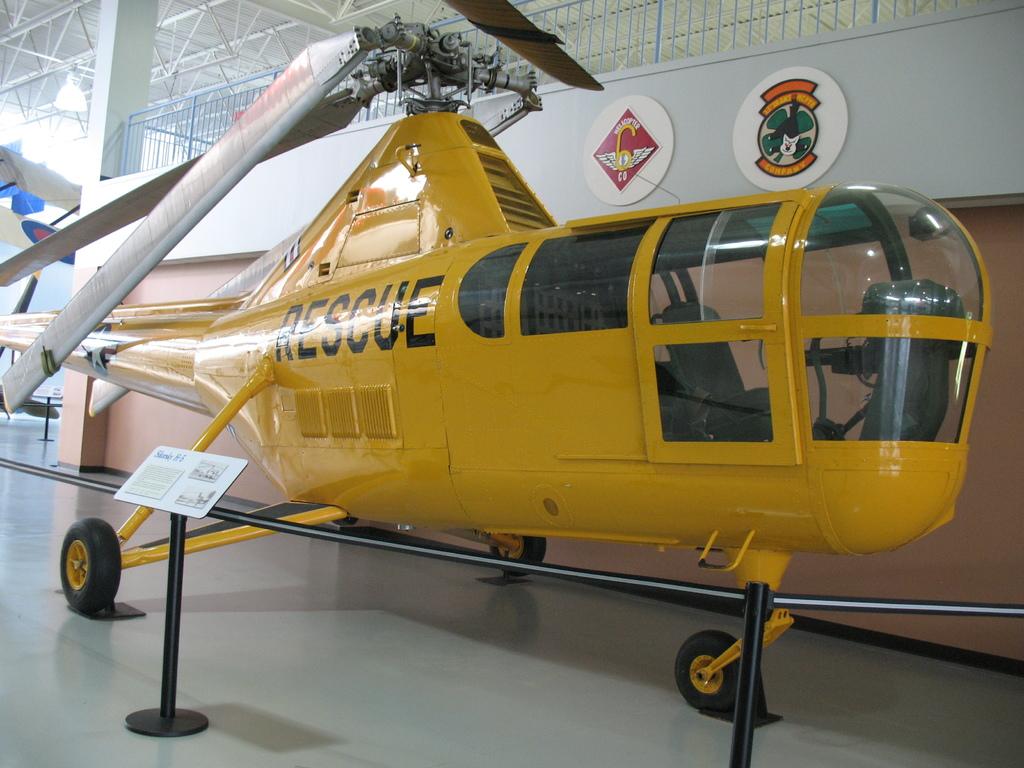What is written on the side of this helicopter?
Make the answer very short. Rescue. What is the first letter of the word?
Provide a short and direct response. R. 